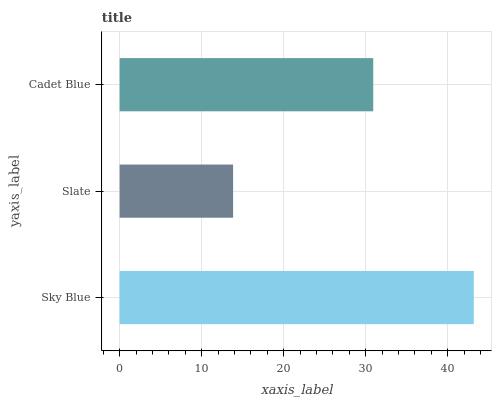Is Slate the minimum?
Answer yes or no. Yes. Is Sky Blue the maximum?
Answer yes or no. Yes. Is Cadet Blue the minimum?
Answer yes or no. No. Is Cadet Blue the maximum?
Answer yes or no. No. Is Cadet Blue greater than Slate?
Answer yes or no. Yes. Is Slate less than Cadet Blue?
Answer yes or no. Yes. Is Slate greater than Cadet Blue?
Answer yes or no. No. Is Cadet Blue less than Slate?
Answer yes or no. No. Is Cadet Blue the high median?
Answer yes or no. Yes. Is Cadet Blue the low median?
Answer yes or no. Yes. Is Slate the high median?
Answer yes or no. No. Is Slate the low median?
Answer yes or no. No. 